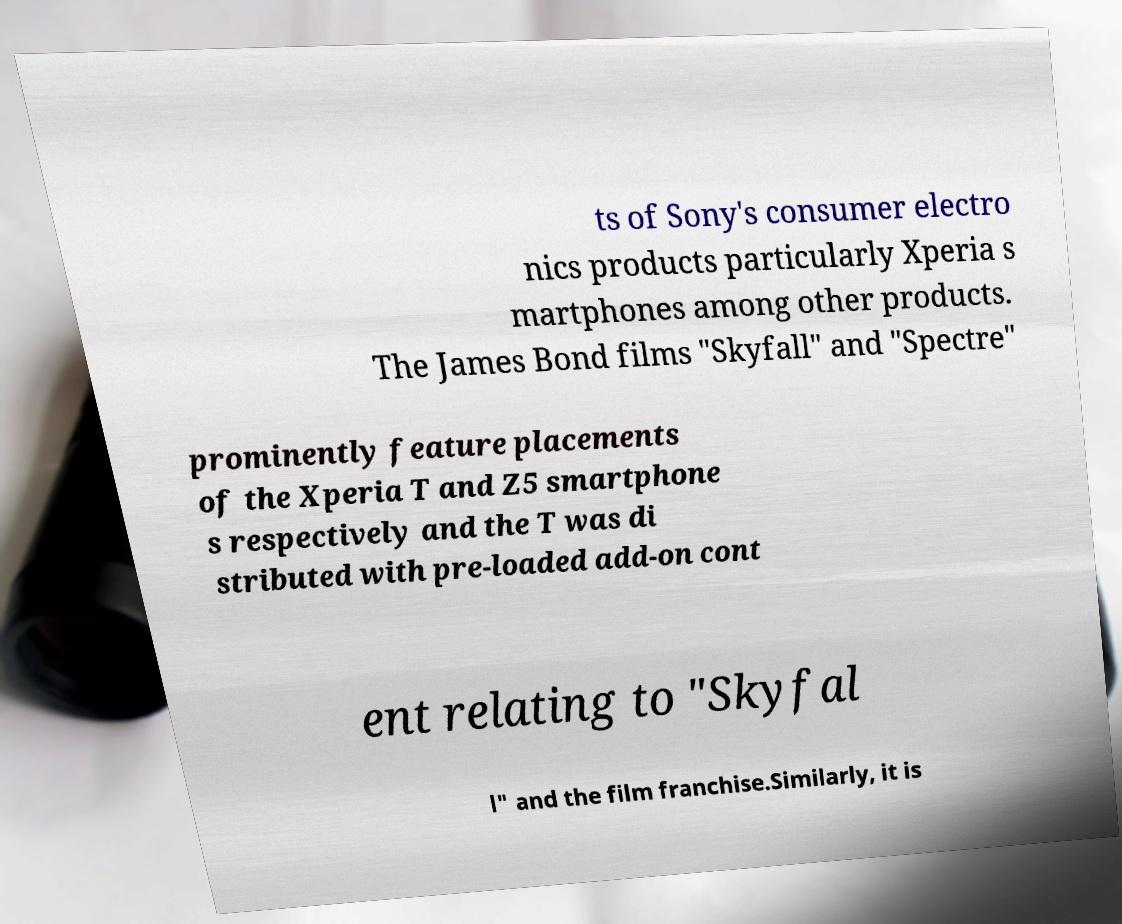There's text embedded in this image that I need extracted. Can you transcribe it verbatim? ts of Sony's consumer electro nics products particularly Xperia s martphones among other products. The James Bond films "Skyfall" and "Spectre" prominently feature placements of the Xperia T and Z5 smartphone s respectively and the T was di stributed with pre-loaded add-on cont ent relating to "Skyfal l" and the film franchise.Similarly, it is 